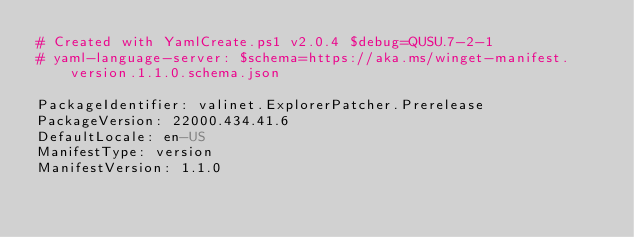Convert code to text. <code><loc_0><loc_0><loc_500><loc_500><_YAML_># Created with YamlCreate.ps1 v2.0.4 $debug=QUSU.7-2-1
# yaml-language-server: $schema=https://aka.ms/winget-manifest.version.1.1.0.schema.json

PackageIdentifier: valinet.ExplorerPatcher.Prerelease
PackageVersion: 22000.434.41.6
DefaultLocale: en-US
ManifestType: version
ManifestVersion: 1.1.0
</code> 